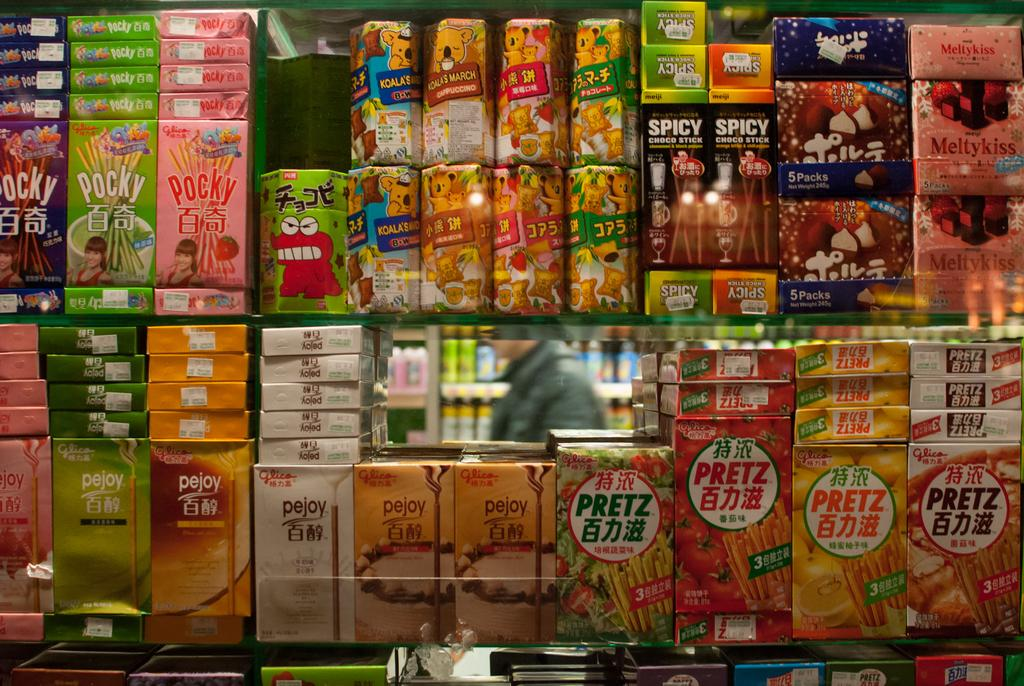<image>
Give a short and clear explanation of the subsequent image. stacks of boxes with some of them labeled as 'pocky' 